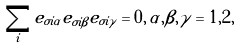Convert formula to latex. <formula><loc_0><loc_0><loc_500><loc_500>\sum _ { i } e _ { \sigma i \alpha } e _ { \sigma i \beta } e _ { \sigma i \gamma } = 0 , \, \alpha , \beta , \gamma = 1 , 2 ,</formula> 